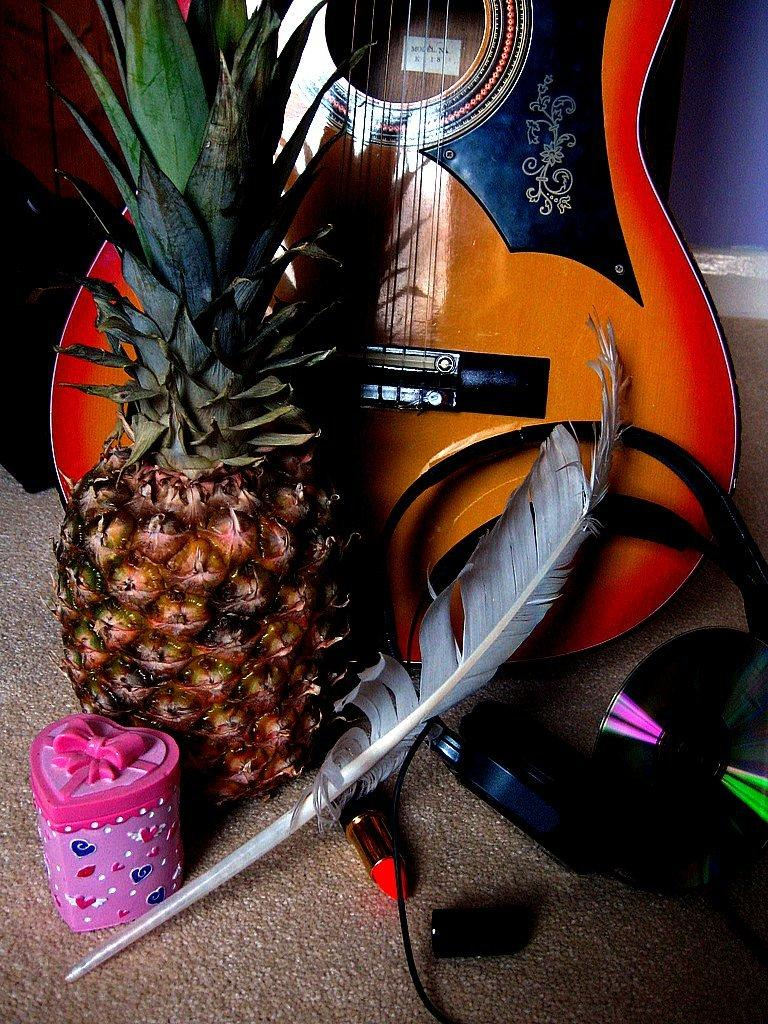What object in the image is typically used for gift-giving? There is a gift box in the image. What item in the image is soft and lightweight? There is a feather in the image. What object in the image is used for storing and playing digital music? There is a CD in the image. What device in the image is used for listening to audio? There is a headset in the image. What fruit is present in the image? There is a pineapple in the image. What musical instrument is in the image? There is a guitar in the image. What is the color of the guitar in the image? The guitar is in a wood color. Who is the creator of the celery in the image? There is no celery present in the image, so it is not possible to determine the creator. 